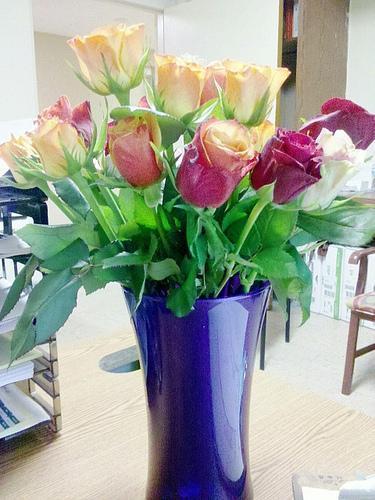How many different color roses are there?
Give a very brief answer. 3. How many white roses are there?
Give a very brief answer. 1. 